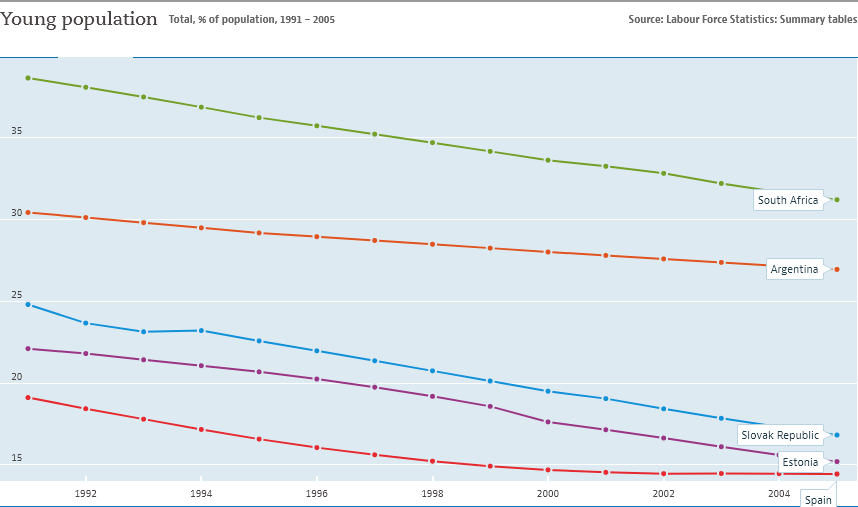Identify some key points in this picture. The chart includes 5 countries. The average value of all the countries became smallest in 2006. 